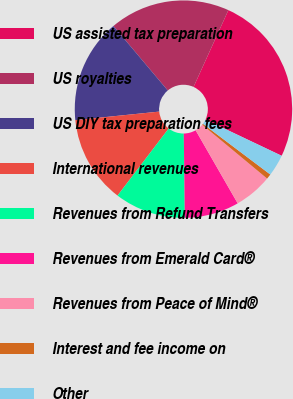Convert chart to OTSL. <chart><loc_0><loc_0><loc_500><loc_500><pie_chart><fcel>US assisted tax preparation<fcel>US royalties<fcel>US DIY tax preparation fees<fcel>International revenues<fcel>Revenues from Refund Transfers<fcel>Revenues from Emerald Card®<fcel>Revenues from Peace of Mind®<fcel>Interest and fee income on<fcel>Other<nl><fcel>25.28%<fcel>17.92%<fcel>15.47%<fcel>13.02%<fcel>10.57%<fcel>8.11%<fcel>5.66%<fcel>0.76%<fcel>3.21%<nl></chart> 